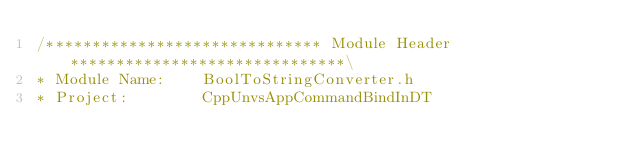Convert code to text. <code><loc_0><loc_0><loc_500><loc_500><_C_>/****************************** Module Header ******************************\
* Module Name:    BoolToStringConverter.h
* Project:        CppUnvsAppCommandBindInDT</code> 